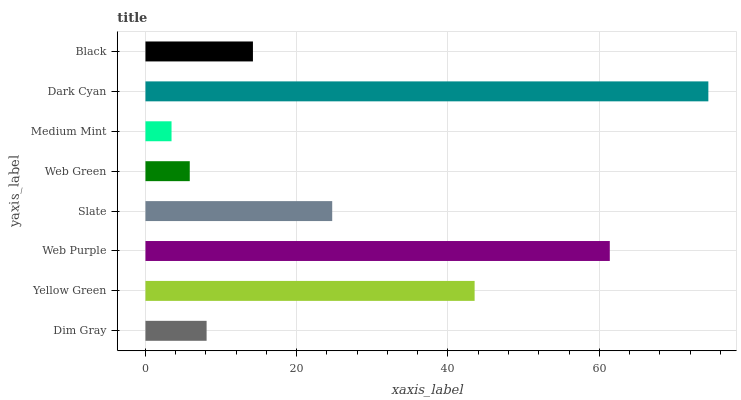Is Medium Mint the minimum?
Answer yes or no. Yes. Is Dark Cyan the maximum?
Answer yes or no. Yes. Is Yellow Green the minimum?
Answer yes or no. No. Is Yellow Green the maximum?
Answer yes or no. No. Is Yellow Green greater than Dim Gray?
Answer yes or no. Yes. Is Dim Gray less than Yellow Green?
Answer yes or no. Yes. Is Dim Gray greater than Yellow Green?
Answer yes or no. No. Is Yellow Green less than Dim Gray?
Answer yes or no. No. Is Slate the high median?
Answer yes or no. Yes. Is Black the low median?
Answer yes or no. Yes. Is Web Purple the high median?
Answer yes or no. No. Is Dim Gray the low median?
Answer yes or no. No. 